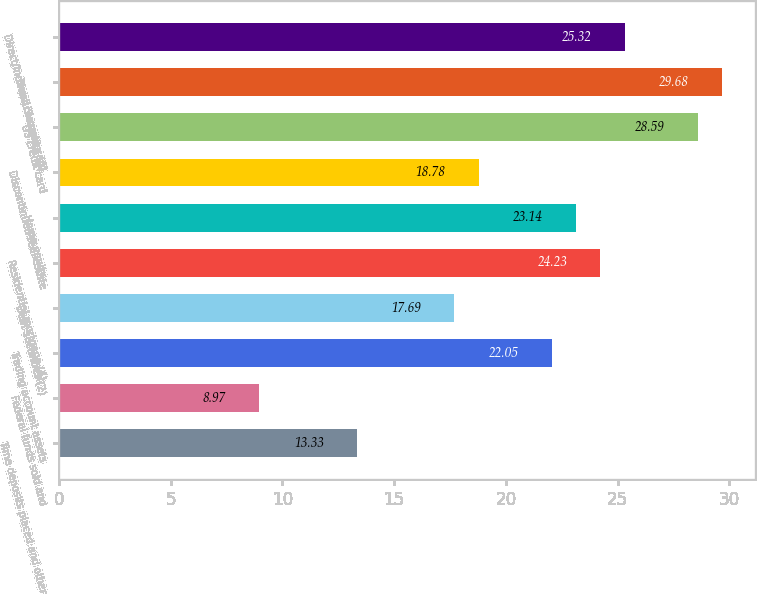Convert chart to OTSL. <chart><loc_0><loc_0><loc_500><loc_500><bar_chart><fcel>Time deposits placed and other<fcel>Federal funds sold and<fcel>Trading account assets<fcel>Debt securities (2)<fcel>Residential mortgage (4)<fcel>Home equity<fcel>Discontinued real estate<fcel>US credit card<fcel>Non-US credit card<fcel>Direct/Indirect consumer (5)<nl><fcel>13.33<fcel>8.97<fcel>22.05<fcel>17.69<fcel>24.23<fcel>23.14<fcel>18.78<fcel>28.59<fcel>29.68<fcel>25.32<nl></chart> 